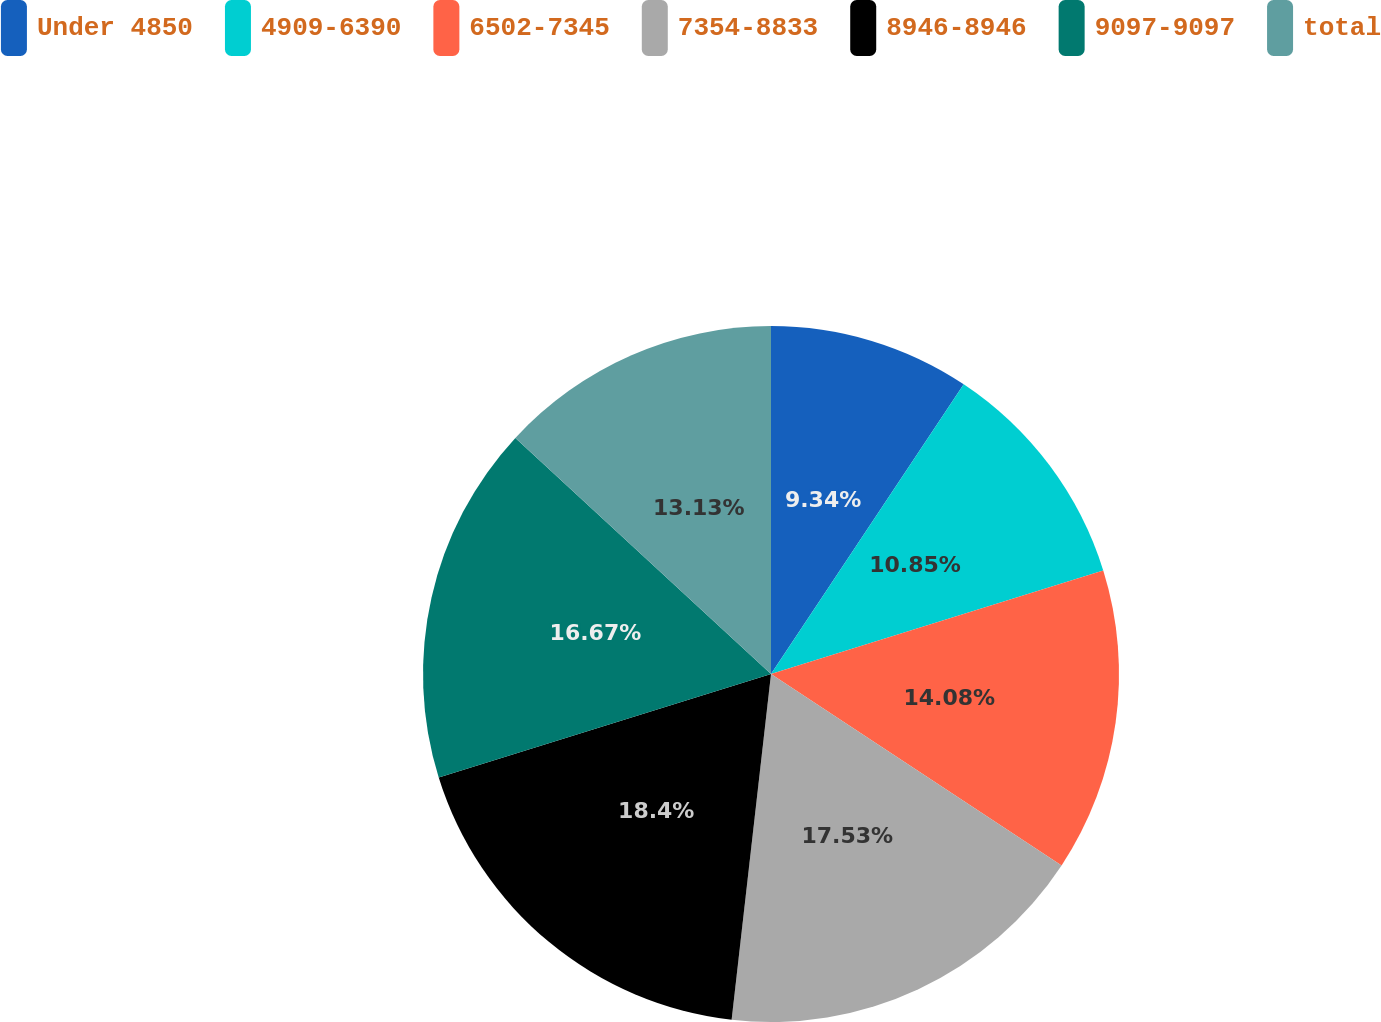<chart> <loc_0><loc_0><loc_500><loc_500><pie_chart><fcel>Under 4850<fcel>4909-6390<fcel>6502-7345<fcel>7354-8833<fcel>8946-8946<fcel>9097-9097<fcel>total<nl><fcel>9.34%<fcel>10.85%<fcel>14.08%<fcel>17.53%<fcel>18.39%<fcel>16.67%<fcel>13.13%<nl></chart> 